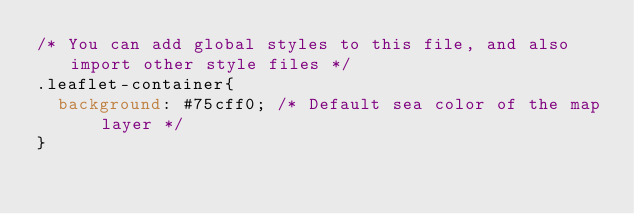<code> <loc_0><loc_0><loc_500><loc_500><_CSS_>/* You can add global styles to this file, and also import other style files */
.leaflet-container{
  background: #75cff0; /* Default sea color of the map layer */
}
</code> 